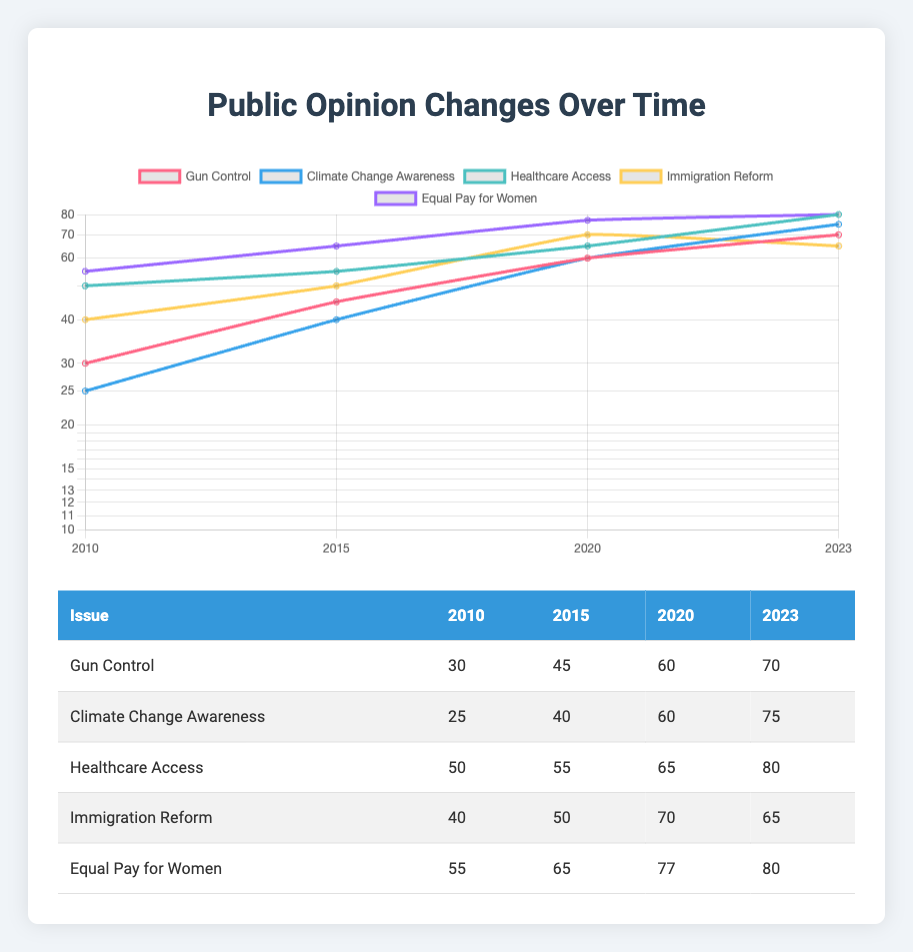What was the public opinion percentage on Gun Control in 2010? Referring to the table, the public opinion percentage on Gun Control in 2010 is readily available in the corresponding row and column.
Answer: 30 Which issue had the highest public opinion percentage in 2023? Looking at the last column of the table for 2023, we see the values: Gun Control (70), Climate Change Awareness (75), Healthcare Access (80), Immigration Reform (65), and Equal Pay for Women (80). Both Healthcare Access and Equal Pay for Women tie for the highest percentage at 80.
Answer: Healthcare Access and Equal Pay for Women What is the percentage increase in public opinion for Climate Change Awareness from 2010 to 2023? The percentage in 2010 was 25 and in 2023 it was 75. To find the increase, subtract the earlier value from the later value: 75 - 25 = 50. Therefore, the increase is 50 percentage points.
Answer: 50 Did public opinion on Immigration Reform increase consistently from 2010 to 2023? Examining the years, in 2010 the opinion was 40, in 2015 it was 50 (increase), in 2020 it was 70 (increase), but then it dropped to 65 in 2023 (decrease). Since there is a decrease in the last step, it did not increase consistently.
Answer: No What is the average public opinion percentage across all issues in 2023? To find the average for 2023, first, sum the percentages: 70 (Gun Control) + 75 (Climate Change Awareness) + 80 (Healthcare Access) + 65 (Immigration Reform) + 80 (Equal Pay for Women) = 370. Then, divide by the number of issues, which is 5: 370 / 5 = 74.
Answer: 74 What was the overall trend in public opinion for Healthcare Access from 2010 to 2023? Looking at the data, the values for Healthcare Access are: 50 (2010), 55 (2015), 65 (2020), and 80 (2023). Each subsequent year shows an increase, indicating a positive trend. Therefore, the overall trend indicates consistent growth in public opinion on this issue.
Answer: Positive trend Is there a difference in public opinion between Equal Pay for Women and Gun Control in 2020? The percentages for Equal Pay for Women and Gun Control in 2020 are 77 and 60, respectively. To see the difference, subtract: 77 - 60 = 17. So, there is a difference of 17 percentage points favoring Equal Pay for Women.
Answer: Yes, 17 points difference What was the public opinion percentage for all issues in 2015, and can you identify the one with the lowest percentage? The percentages for 2015 are: Gun Control (45), Climate Change Awareness (40), Healthcare Access (55), Immigration Reform (50), and Equal Pay for Women (65). Out of these, Climate Change Awareness has the lowest percentage at 40.
Answer: Climate Change Awareness, 40 